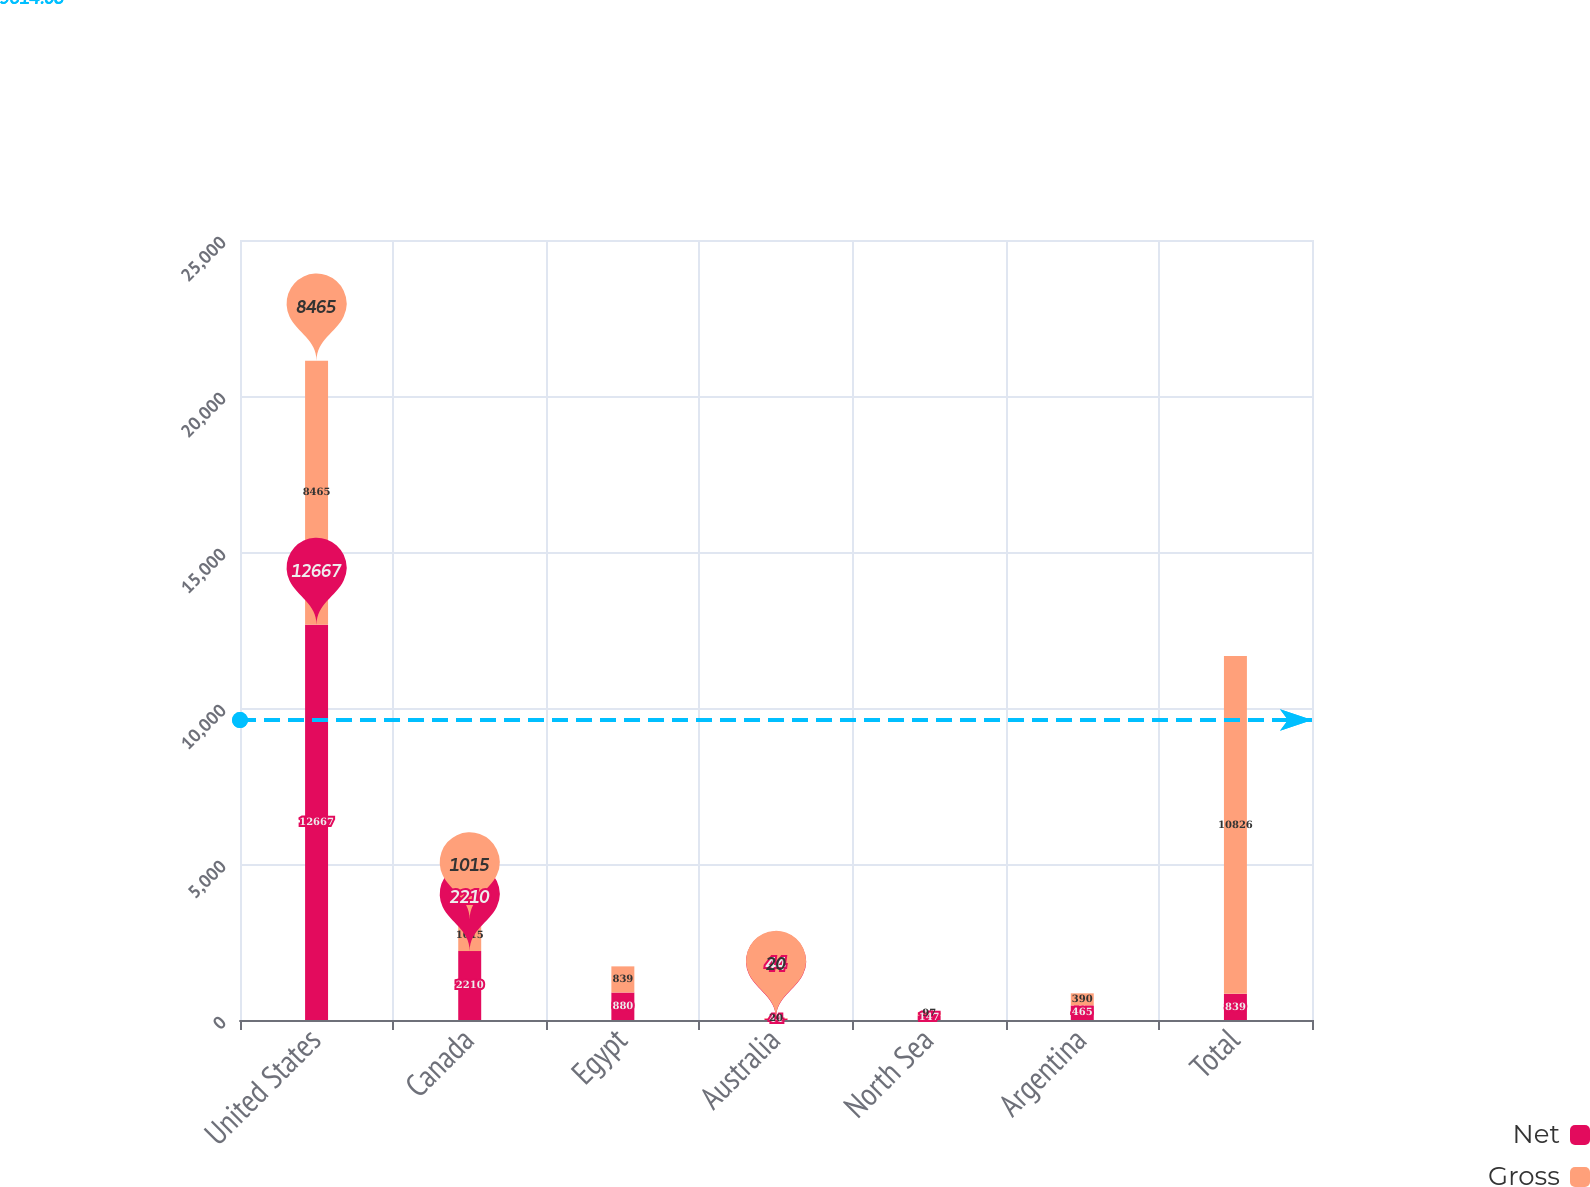Convert chart to OTSL. <chart><loc_0><loc_0><loc_500><loc_500><stacked_bar_chart><ecel><fcel>United States<fcel>Canada<fcel>Egypt<fcel>Australia<fcel>North Sea<fcel>Argentina<fcel>Total<nl><fcel>Net<fcel>12667<fcel>2210<fcel>880<fcel>44<fcel>147<fcel>465<fcel>839<nl><fcel>Gross<fcel>8465<fcel>1015<fcel>839<fcel>20<fcel>97<fcel>390<fcel>10826<nl></chart> 